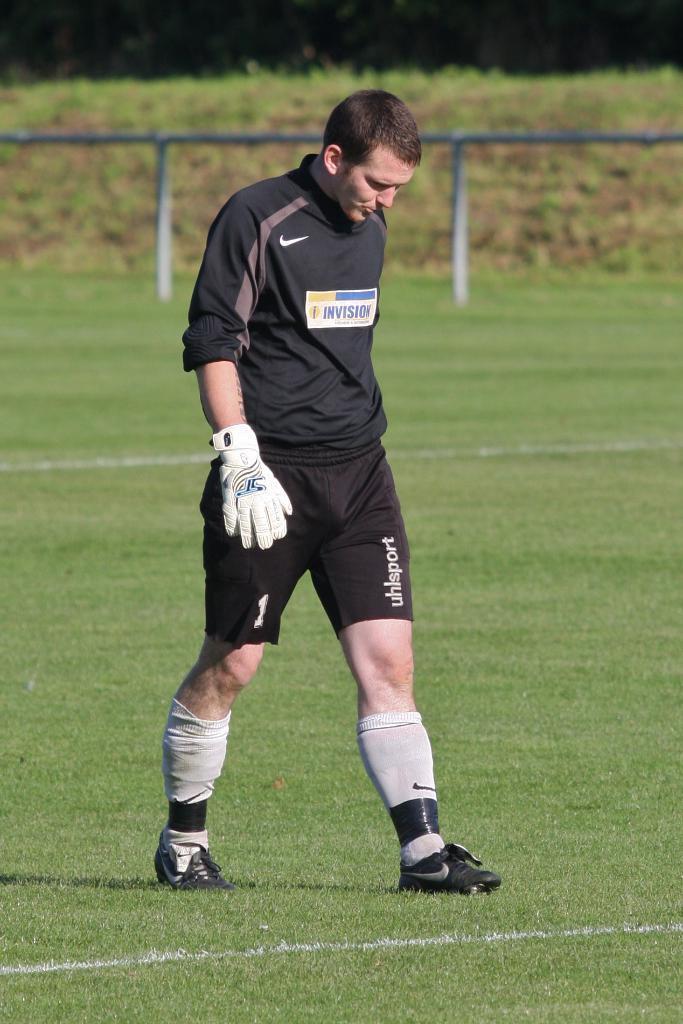Could you give a brief overview of what you see in this image? In the center of the image a person is standing and wearing a glove. In the background of the image we can see ground is present. At the top of the image rods are there. 